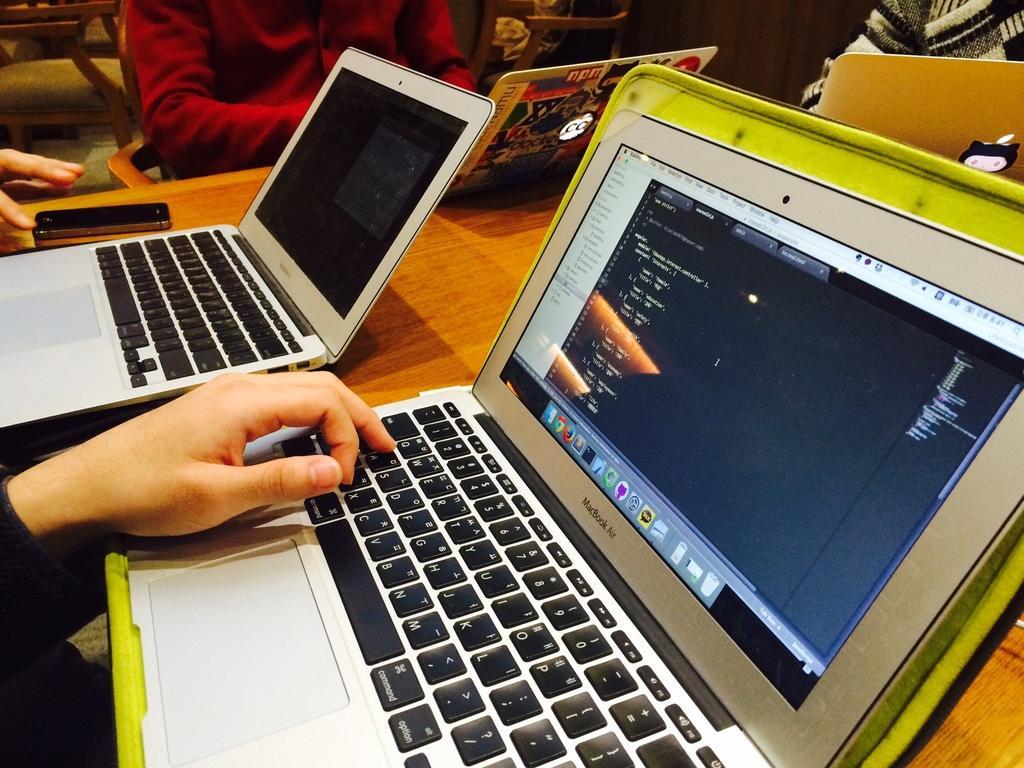Describe this image in one or two sentences. In this picture we can see a few laptops and a phone on a wooden table. There are few people and a chair is visible in the background. 